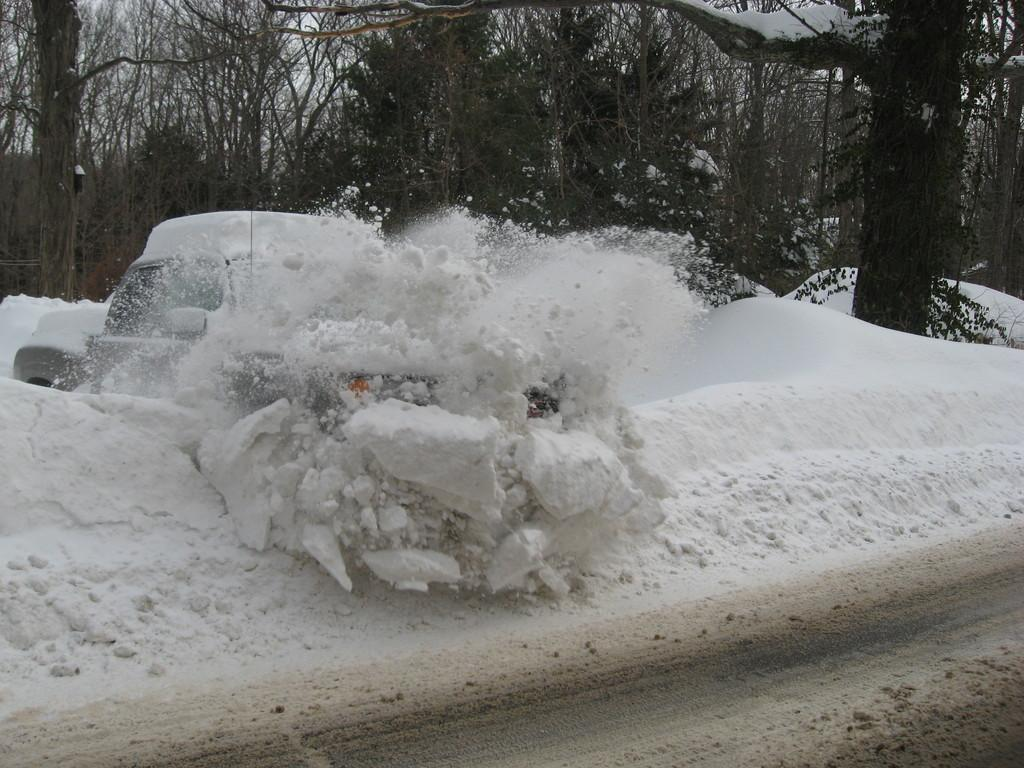What is the primary weather condition depicted in the image? There is snow in the image. What object is covered with snow in the image? There is a vehicle covered with snow. What type of natural scenery can be seen in the background of the image? Trees covered with snow are visible in the background of the image. What type of metal is used to make the brake on the vehicle in the image? There is no information about the type of metal used for the brake on the vehicle in the image, nor is there any indication that the brake is visible. 